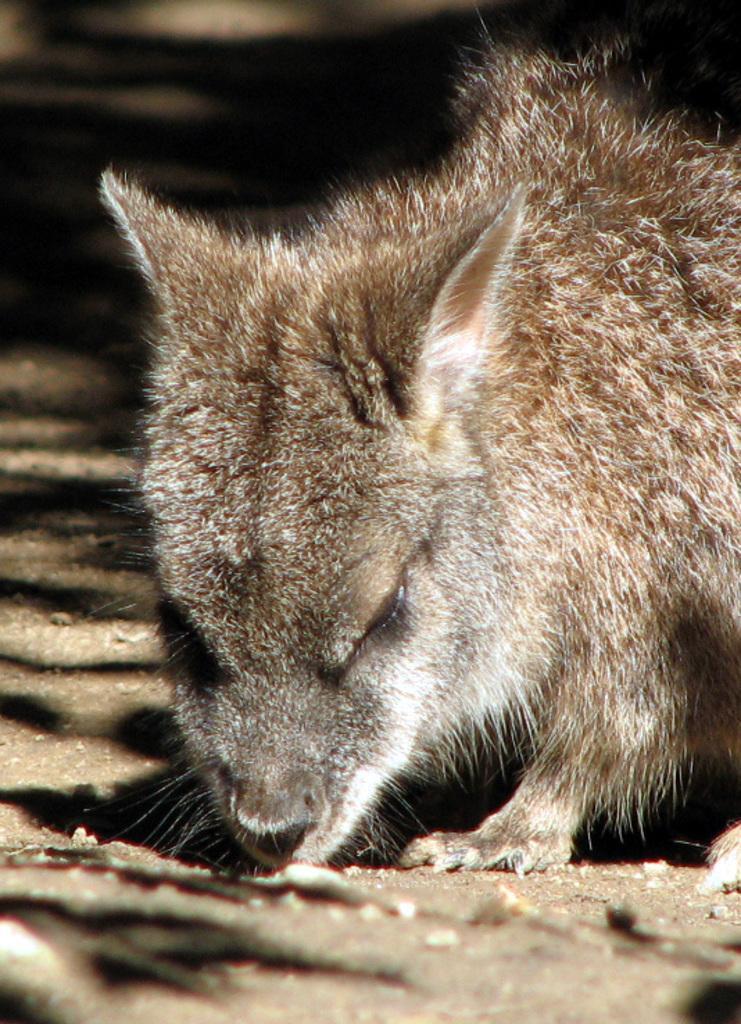In one or two sentences, can you explain what this image depicts? In the image we can see there is an animal standing on the ground. 